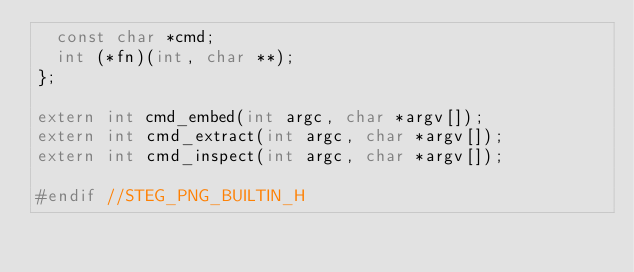<code> <loc_0><loc_0><loc_500><loc_500><_C_>	const char *cmd;
	int (*fn)(int, char **);
};

extern int cmd_embed(int argc, char *argv[]);
extern int cmd_extract(int argc, char *argv[]);
extern int cmd_inspect(int argc, char *argv[]);

#endif //STEG_PNG_BUILTIN_H
</code> 